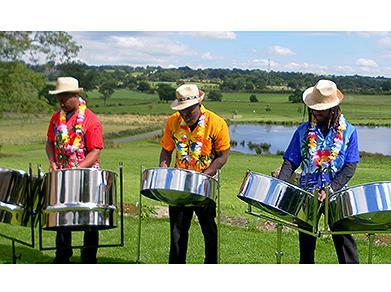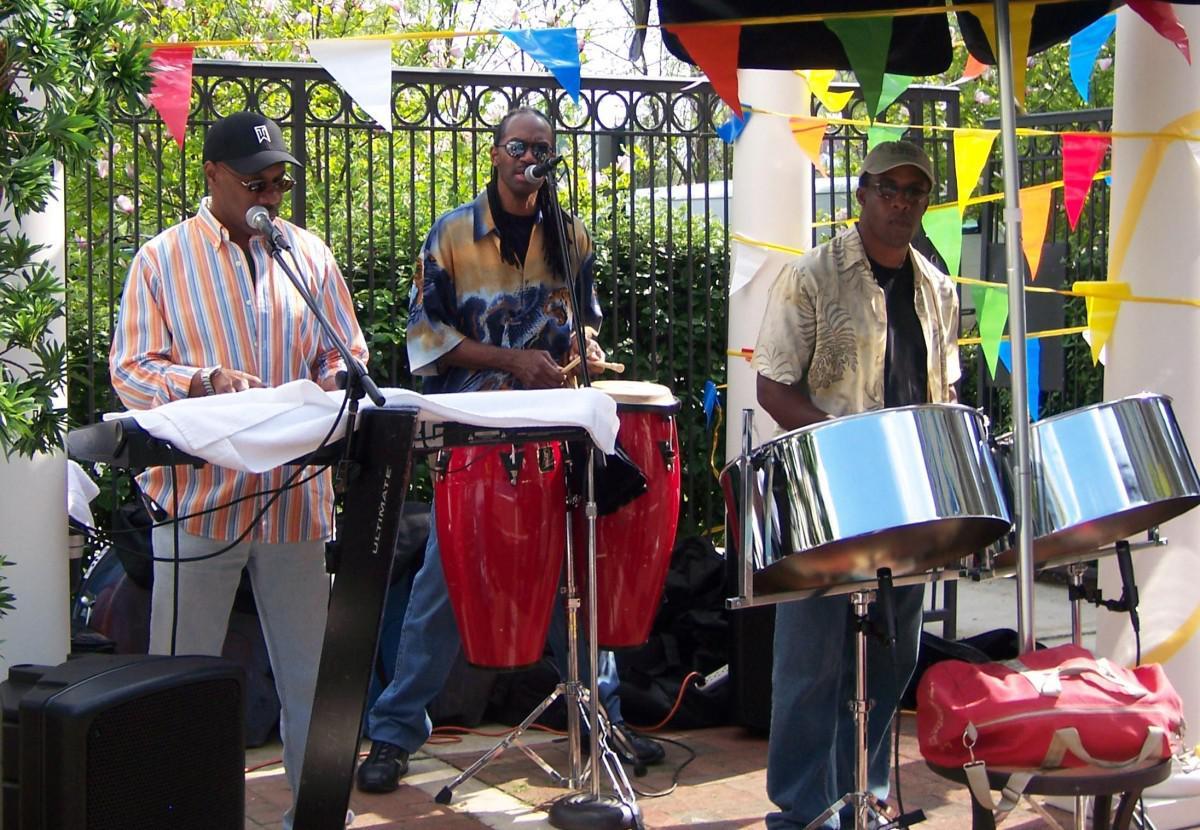The first image is the image on the left, the second image is the image on the right. For the images displayed, is the sentence "One image features three men in hats and leis and hawaiian shirts standing behind silver metal drums on pivoting stands." factually correct? Answer yes or no. Yes. The first image is the image on the left, the second image is the image on the right. Examine the images to the left and right. Is the description "In one image all the musicians are wearing hats." accurate? Answer yes or no. Yes. 